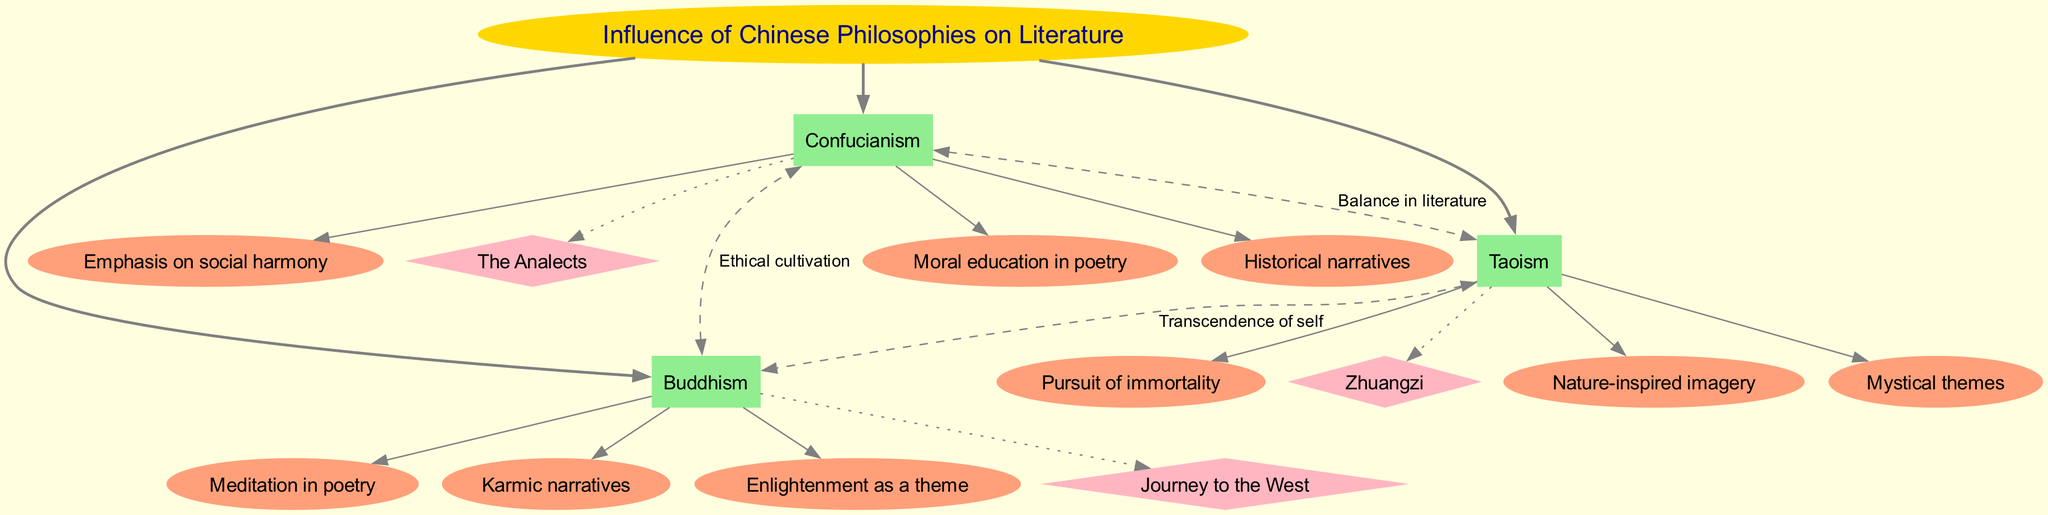What are the three main branches of philosophy depicted in the diagram? The diagram explicitly lists three main branches: Confucianism, Taoism, and Buddhism, which are positioned as the main branches stemming from the central topic.
Answer: Confucianism, Taoism, Buddhism How many sub-branches does Confucianism have? The diagram shows three sub-branches branching from Confucianism: moral education in poetry, historical narratives, and emphasis on social harmony. Thus, we summarize this by counting the visible sub-branches.
Answer: 3 Which philosophy is linked to "Meditation in poetry"? The work related to "Meditation in poetry" is listed under Buddhism as one of its sub-branches in the diagram.
Answer: Buddhism What is the label of the cross-connection from Taoism to Buddhism? The cross-connection from Taoism to Buddhism is labeled "Transcendence of self," which can be found directly on the connecting edge in the diagram.
Answer: Transcendence of self How many examples are listed for the influence of Confucianism on literature? The diagram includes one specific example of a literary work influenced by Confucianism, which is "The Analects." This can be observed by checking the example section related to Confucianism.
Answer: 1 What are the mystical themes associated with which philosophy? The diagram connects mystical themes specifically to Taoism, as indicated under the sub-branches of Taoism in the diagram.
Answer: Taoism Which two philosophies are connected through the label "Balance in literature"? The diagram shows that Confucianism and Taoism are related by the label "Balance in literature," identified by tracing the connecting edge between the two nodes.
Answer: Confucianism, Taoism What is emphasized in the historical narratives? The historical narratives are emphasized under the Confucianism branch, which can be found as one of the sub-branches in the diagram associated with that philosophy.
Answer: Confucianism 